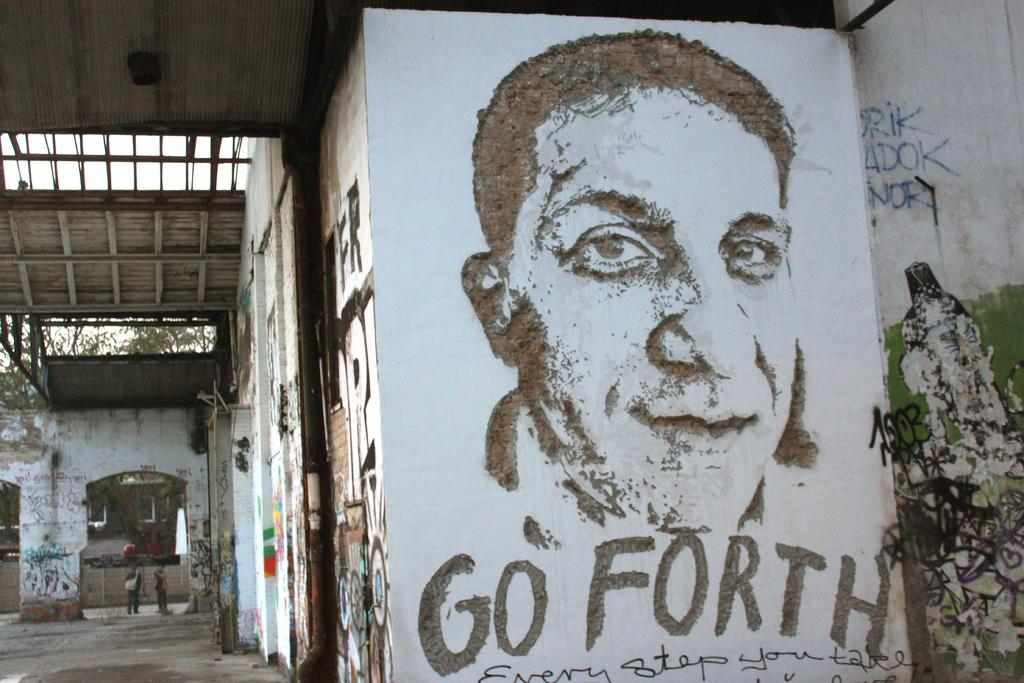What is present on the wall in the image? There is a picture of a person on the wall. Is there any text associated with the picture on the wall? Yes, there is text associated with the picture on the wall. What can be seen on the floor in the image? The floor is visible in the image. What type of natural elements are present in the image? There are trees and the sky visible in the image. What type of territory is being claimed by the cannon in the image? There is no cannon present in the image, so no territory is being claimed. How does the person in the picture care for the trees in the image? The person in the picture is not actively caring for the trees in the image, as it is a static image. 